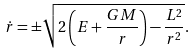<formula> <loc_0><loc_0><loc_500><loc_500>\dot { r } = \pm \sqrt { 2 \left ( E + \frac { G M } { r } \right ) - \frac { L ^ { 2 } } { r ^ { 2 } } } .</formula> 